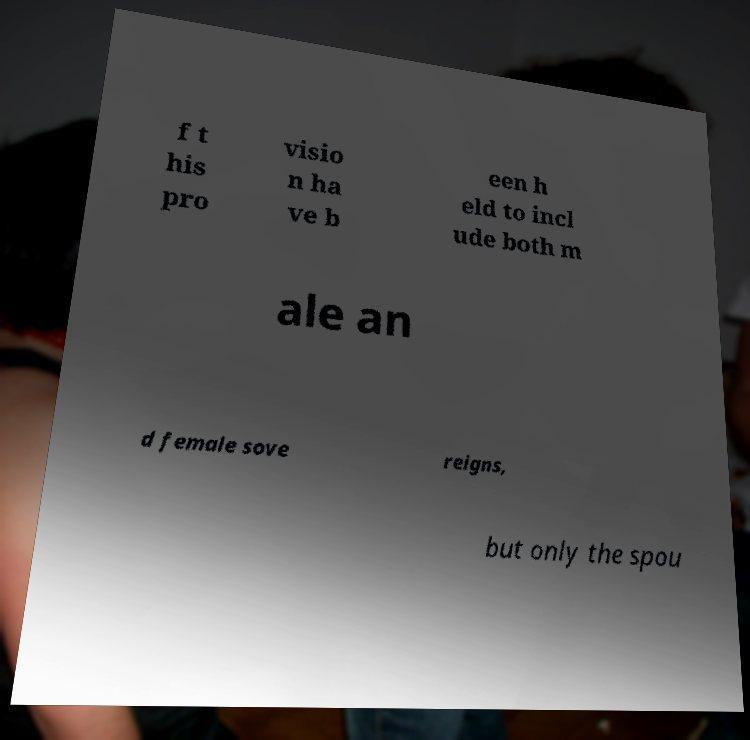Could you assist in decoding the text presented in this image and type it out clearly? f t his pro visio n ha ve b een h eld to incl ude both m ale an d female sove reigns, but only the spou 